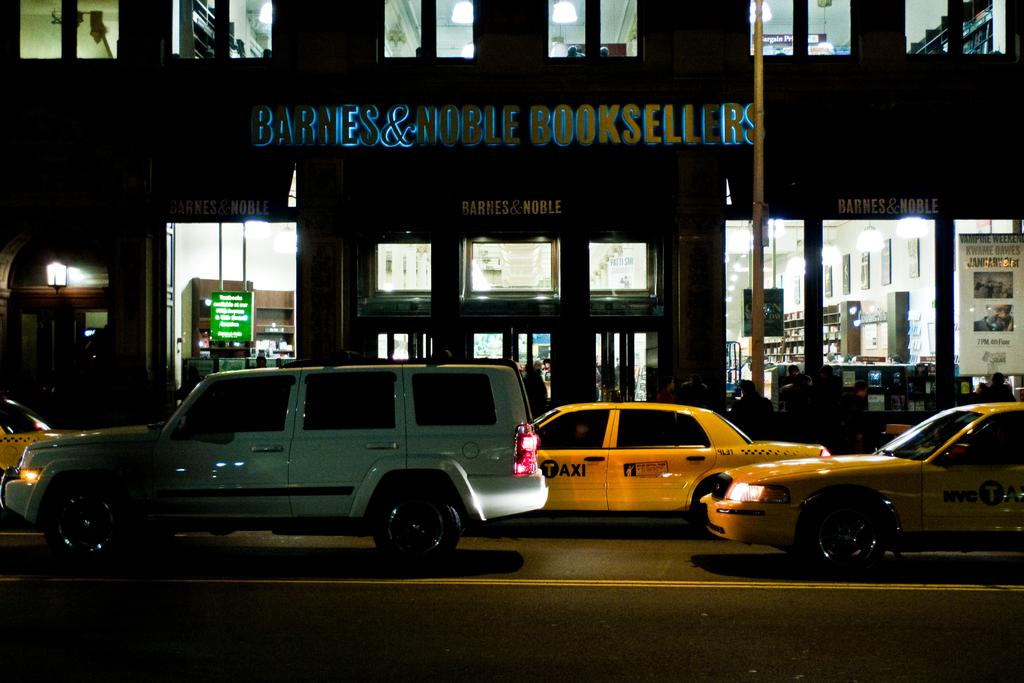<image>
Provide a brief description of the given image. a Book sellers store that has a yellow car next to it 